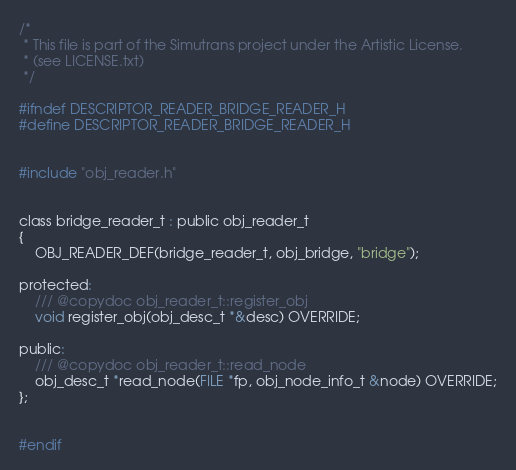Convert code to text. <code><loc_0><loc_0><loc_500><loc_500><_C_>/*
 * This file is part of the Simutrans project under the Artistic License.
 * (see LICENSE.txt)
 */

#ifndef DESCRIPTOR_READER_BRIDGE_READER_H
#define DESCRIPTOR_READER_BRIDGE_READER_H


#include "obj_reader.h"


class bridge_reader_t : public obj_reader_t
{
	OBJ_READER_DEF(bridge_reader_t, obj_bridge, "bridge");

protected:
	/// @copydoc obj_reader_t::register_obj
	void register_obj(obj_desc_t *&desc) OVERRIDE;

public:
	/// @copydoc obj_reader_t::read_node
	obj_desc_t *read_node(FILE *fp, obj_node_info_t &node) OVERRIDE;
};


#endif
</code> 